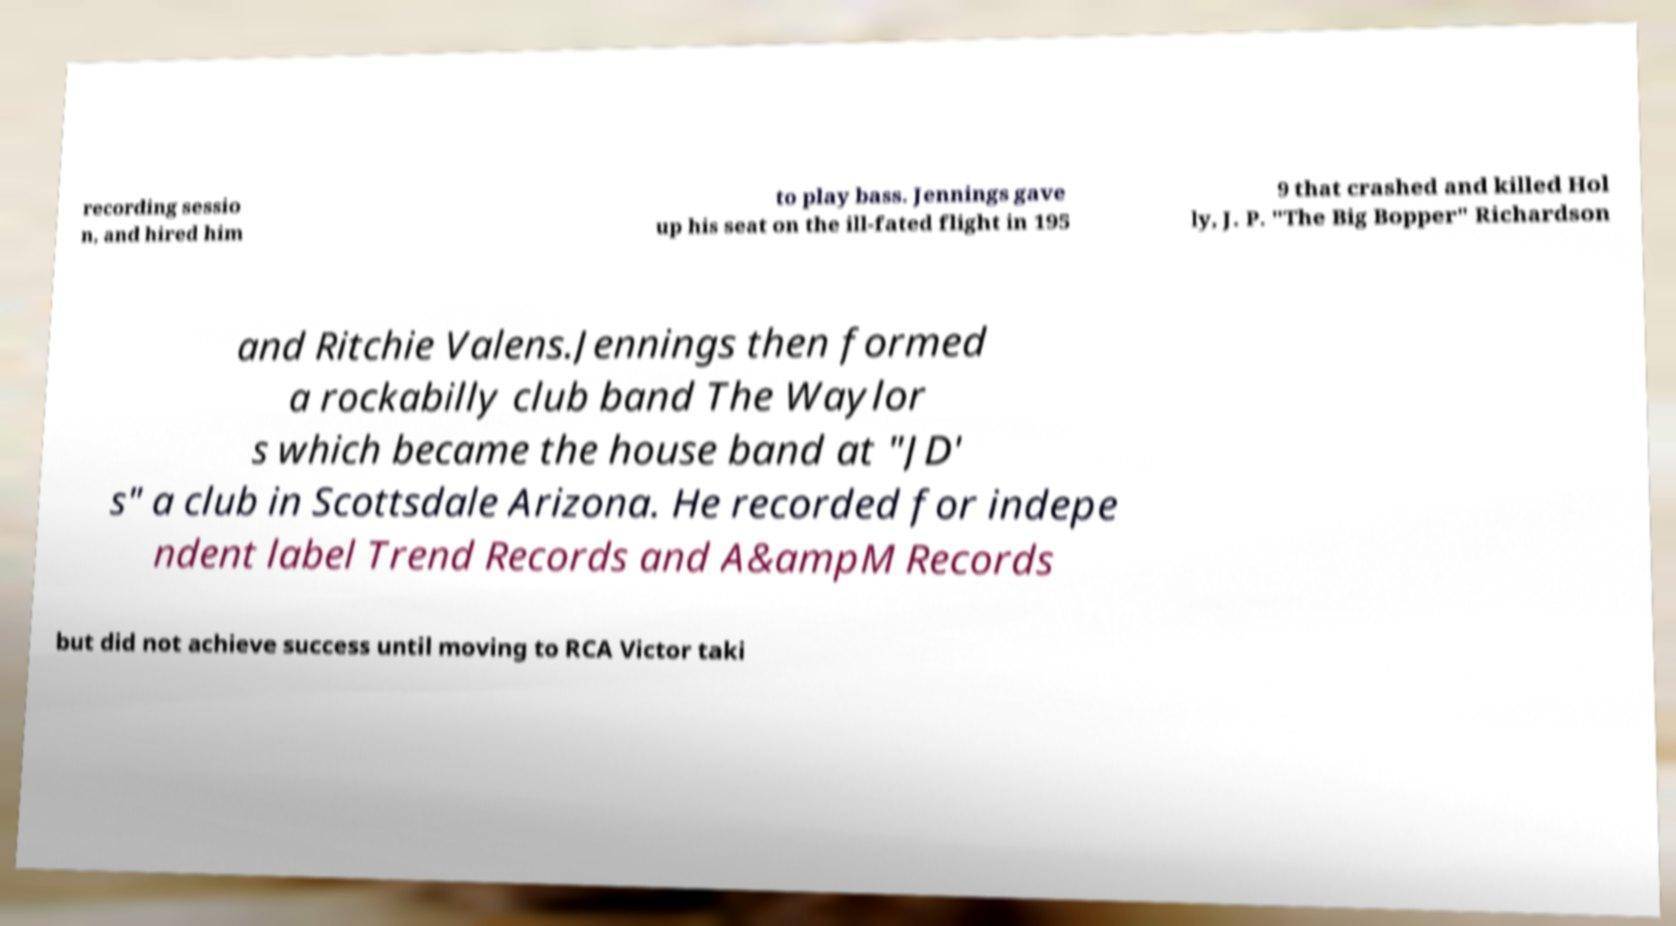Please identify and transcribe the text found in this image. recording sessio n, and hired him to play bass. Jennings gave up his seat on the ill-fated flight in 195 9 that crashed and killed Hol ly, J. P. "The Big Bopper" Richardson and Ritchie Valens.Jennings then formed a rockabilly club band The Waylor s which became the house band at "JD' s" a club in Scottsdale Arizona. He recorded for indepe ndent label Trend Records and A&ampM Records but did not achieve success until moving to RCA Victor taki 